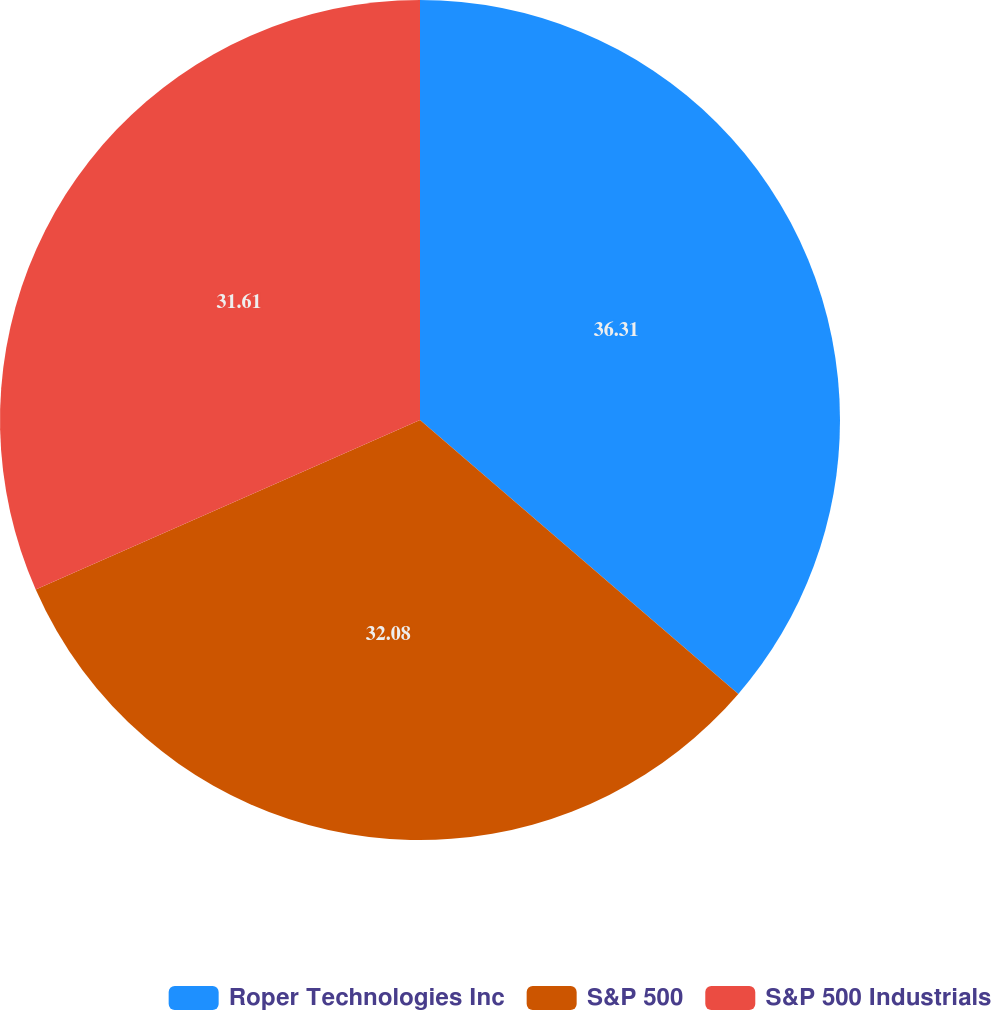Convert chart. <chart><loc_0><loc_0><loc_500><loc_500><pie_chart><fcel>Roper Technologies Inc<fcel>S&P 500<fcel>S&P 500 Industrials<nl><fcel>36.31%<fcel>32.08%<fcel>31.61%<nl></chart> 